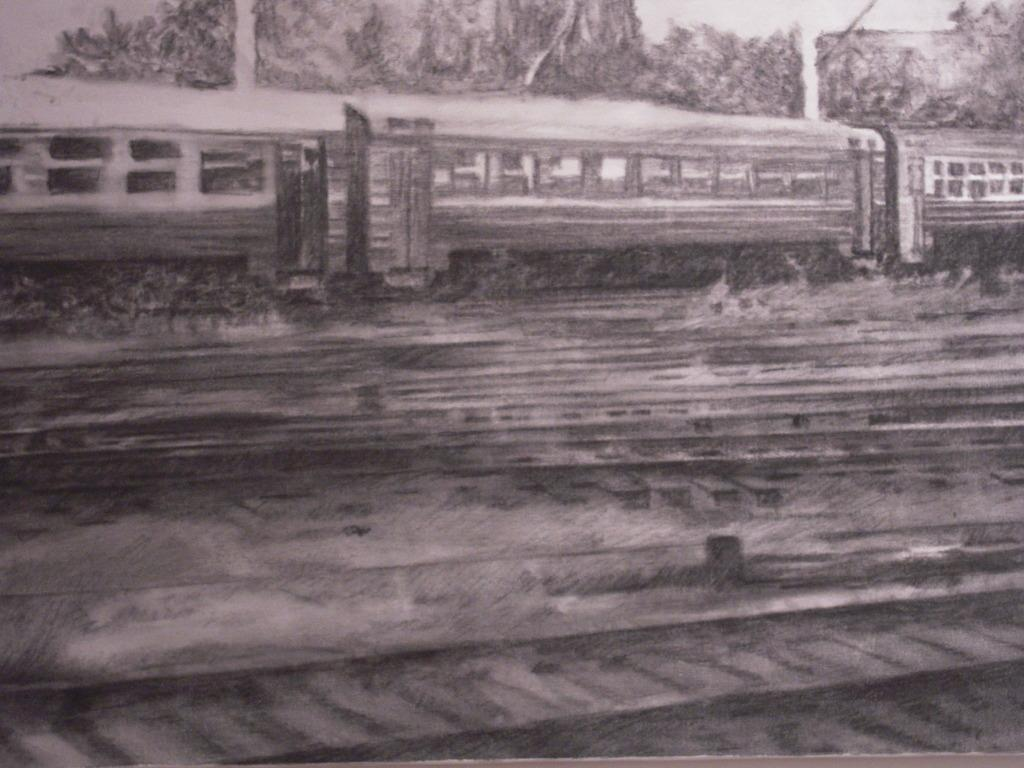What is the main subject of the image? The image contains a photograph. What can be seen on the photograph? The photograph shows tracks and a train on the tracks. What is visible in the background of the photograph? There are trees and the sky visible in the background of the photograph. What color is the sock hanging on the train in the image? There is no sock present in the image; it features a photograph of a train on tracks with trees and the sky in the background. 